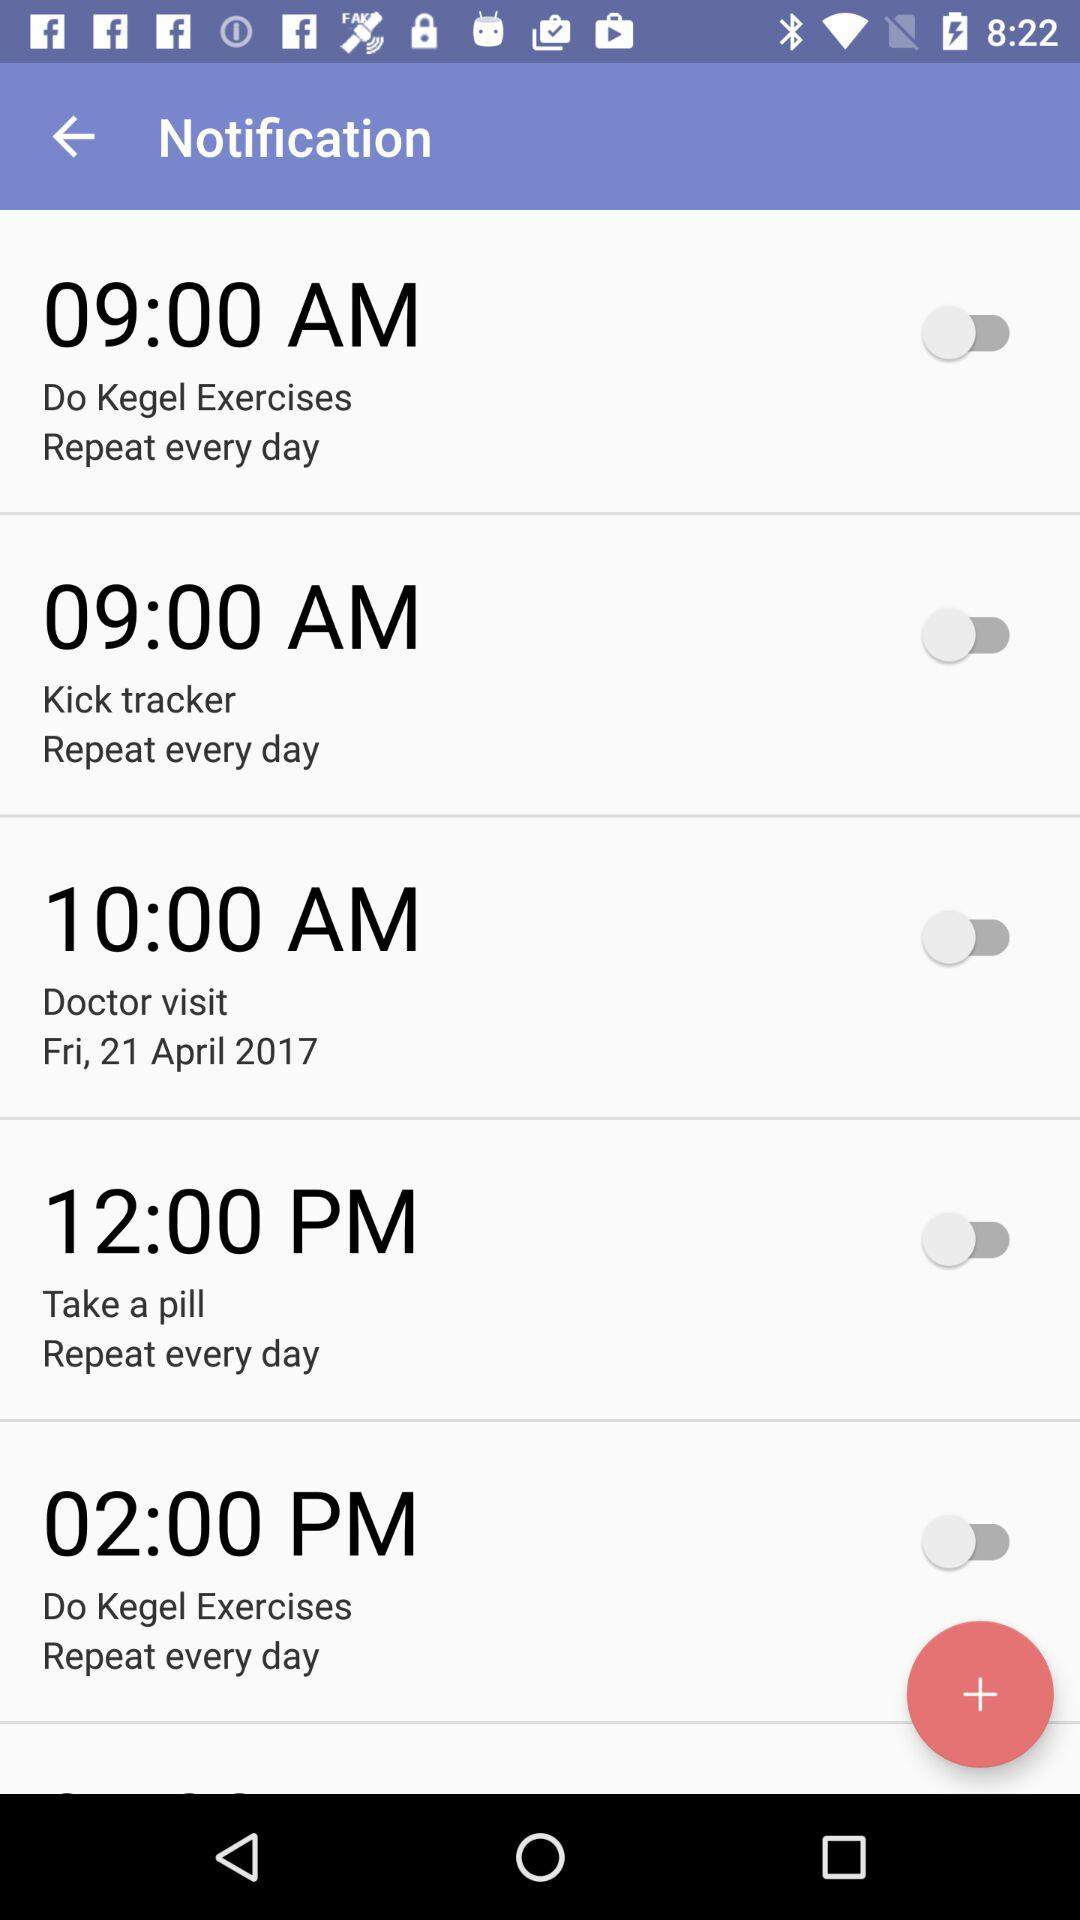What is the time to do kick tracker exercise? The time is 9:00 AM. 